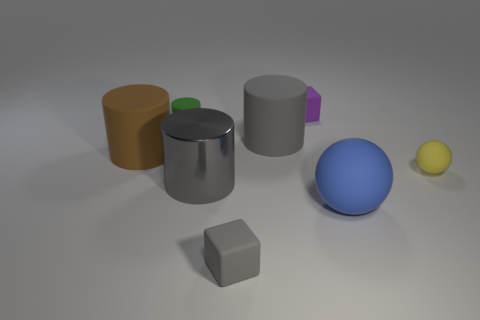What is the size comparison between the objects? If we compare sizes, we can see there are larger and smaller variants of similar shapes. For instance, the blue sphere is noticeably larger than the yellow one. Among the cubes, the blue one is the largest, and the gray one is the smallest. As for the cylinders, the orange one is shorter and wider than the tall gray one. The height of the green cube approximately matches the diameter of the smaller yellow sphere. 